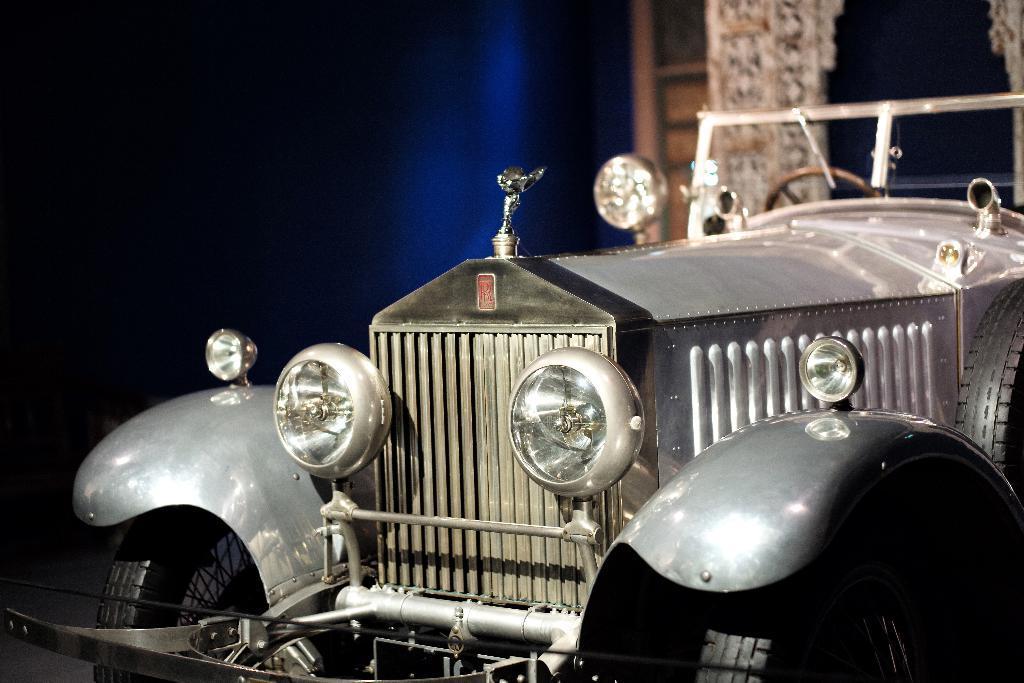In one or two sentences, can you explain what this image depicts? In the center of the image we can see a vehicle. At the top of the image we can see the wall and wood. In the bottom left corner we can see the floor. 